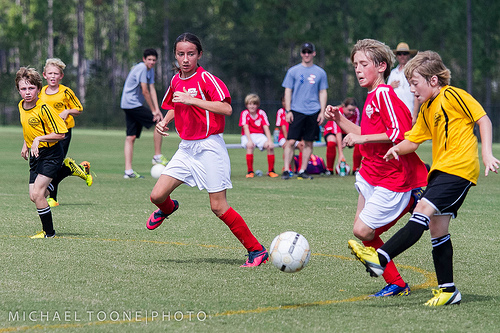<image>
Is the ball next to the player? No. The ball is not positioned next to the player. They are located in different areas of the scene. Is the soccer ball in front of the shoe? Yes. The soccer ball is positioned in front of the shoe, appearing closer to the camera viewpoint. 